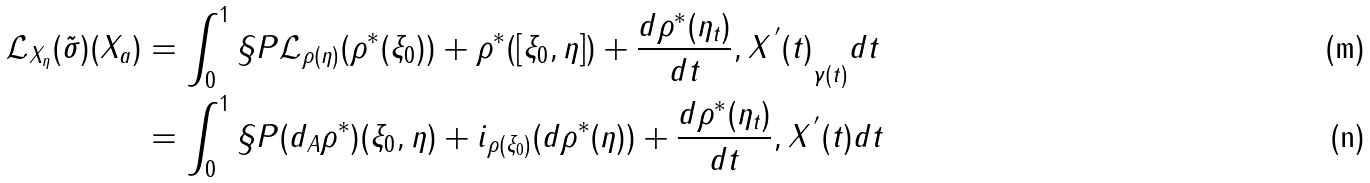Convert formula to latex. <formula><loc_0><loc_0><loc_500><loc_500>\mathcal { L } _ { X _ { \eta } } ( \tilde { \sigma } ) ( X _ { a } ) & = \int _ { 0 } ^ { 1 } \S P { \mathcal { L } _ { \rho ( \eta ) } ( \rho ^ { * } ( \xi _ { 0 } ) ) + \rho ^ { * } ( [ \xi _ { 0 } , \eta ] ) + \frac { d \rho ^ { * } ( \eta _ { t } ) } { d t } , X ^ { \, ^ { \prime } } ( t ) } _ { \gamma ( t ) } d t \\ & = \int _ { 0 } ^ { 1 } \S P { ( d _ { A } \rho ^ { * } ) ( \xi _ { 0 } , \eta ) + i _ { \rho ( \xi _ { 0 } ) } ( d \rho ^ { * } ( \eta ) ) + \frac { d \rho ^ { * } ( \eta _ { t } ) } { d t } , X ^ { \, ^ { \prime } } ( t ) } d t</formula> 